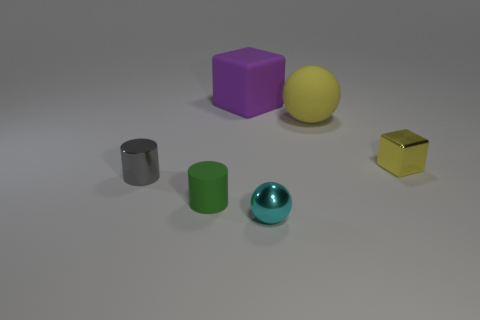How many tiny spheres are made of the same material as the small green thing?
Provide a short and direct response. 0. Is the small yellow thing the same shape as the large yellow rubber object?
Keep it short and to the point. No. There is a yellow thing that is behind the tiny thing to the right of the ball that is in front of the gray cylinder; what size is it?
Offer a terse response. Large. Is there a yellow matte thing that is in front of the small shiny object on the left side of the large purple rubber thing?
Keep it short and to the point. No. There is a large object that is in front of the cube that is behind the metal cube; how many cyan objects are to the right of it?
Provide a short and direct response. 0. What is the color of the object that is both on the left side of the purple rubber cube and right of the tiny gray cylinder?
Keep it short and to the point. Green. How many other small metal cylinders are the same color as the tiny metal cylinder?
Your answer should be very brief. 0. What number of blocks are small yellow objects or gray objects?
Keep it short and to the point. 1. There is another cylinder that is the same size as the green matte cylinder; what is its color?
Give a very brief answer. Gray. Are there any matte objects that are behind the tiny metallic object that is behind the small shiny thing that is to the left of the large rubber cube?
Ensure brevity in your answer.  Yes. 